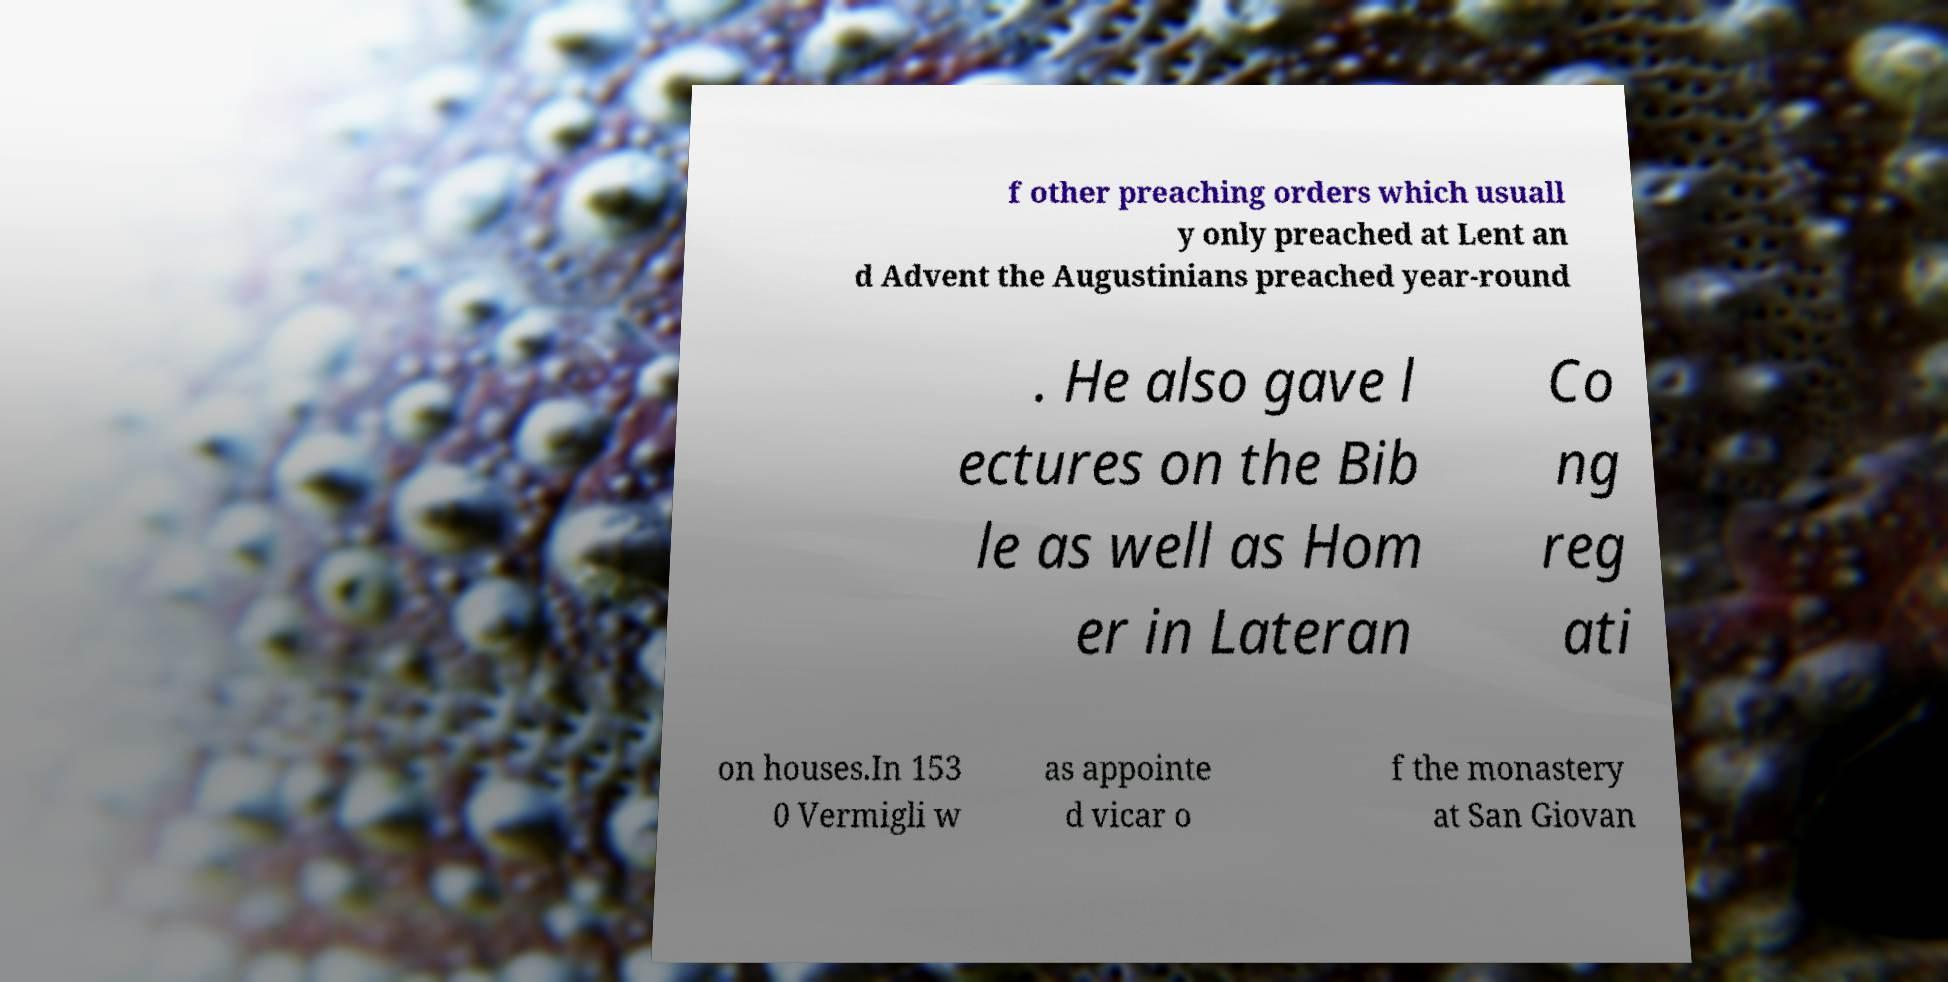What messages or text are displayed in this image? I need them in a readable, typed format. f other preaching orders which usuall y only preached at Lent an d Advent the Augustinians preached year-round . He also gave l ectures on the Bib le as well as Hom er in Lateran Co ng reg ati on houses.In 153 0 Vermigli w as appointe d vicar o f the monastery at San Giovan 